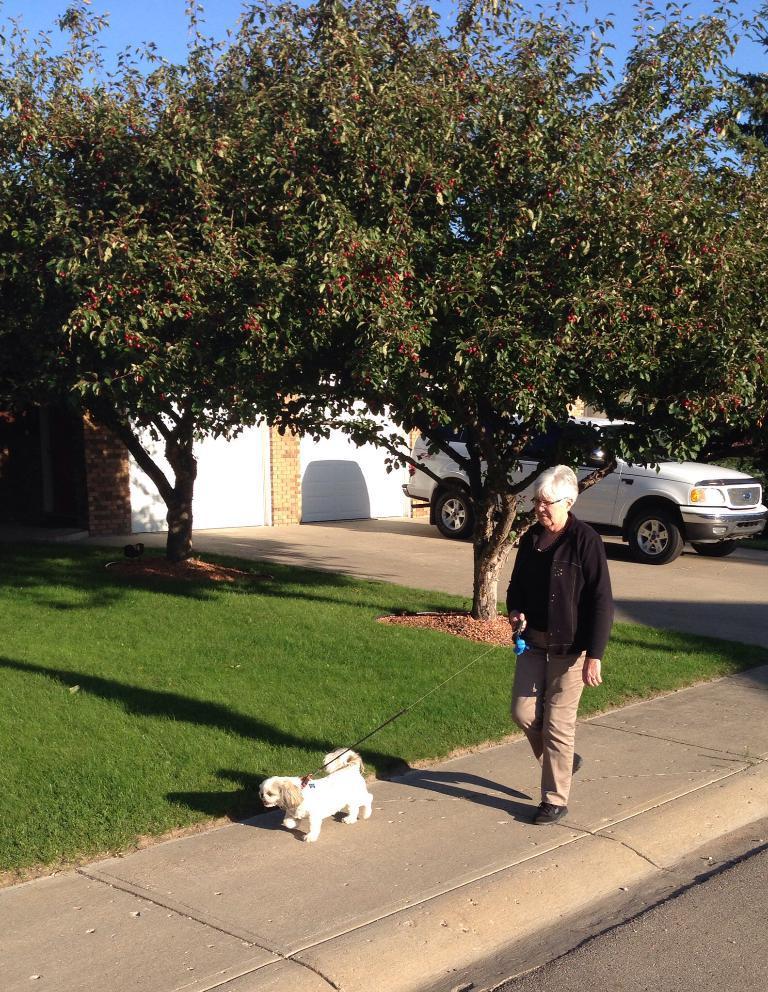Could you give a brief overview of what you see in this image? In this image there is a woman taking her dog for a walk on the pavement, beside the pavement there are two trees and there is grass on the surface, behind the trees there is a car parked in front of a closed shutter. 